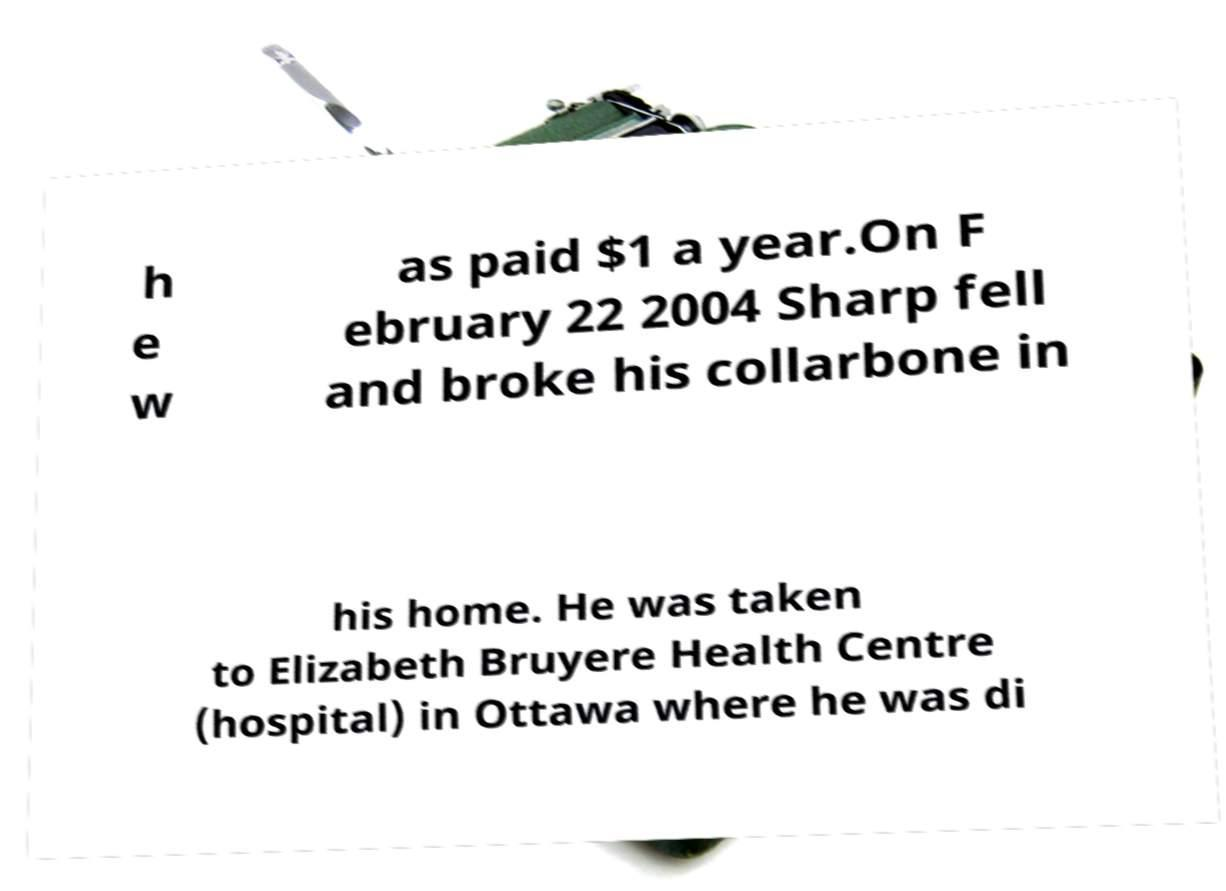For documentation purposes, I need the text within this image transcribed. Could you provide that? h e w as paid $1 a year.On F ebruary 22 2004 Sharp fell and broke his collarbone in his home. He was taken to Elizabeth Bruyere Health Centre (hospital) in Ottawa where he was di 